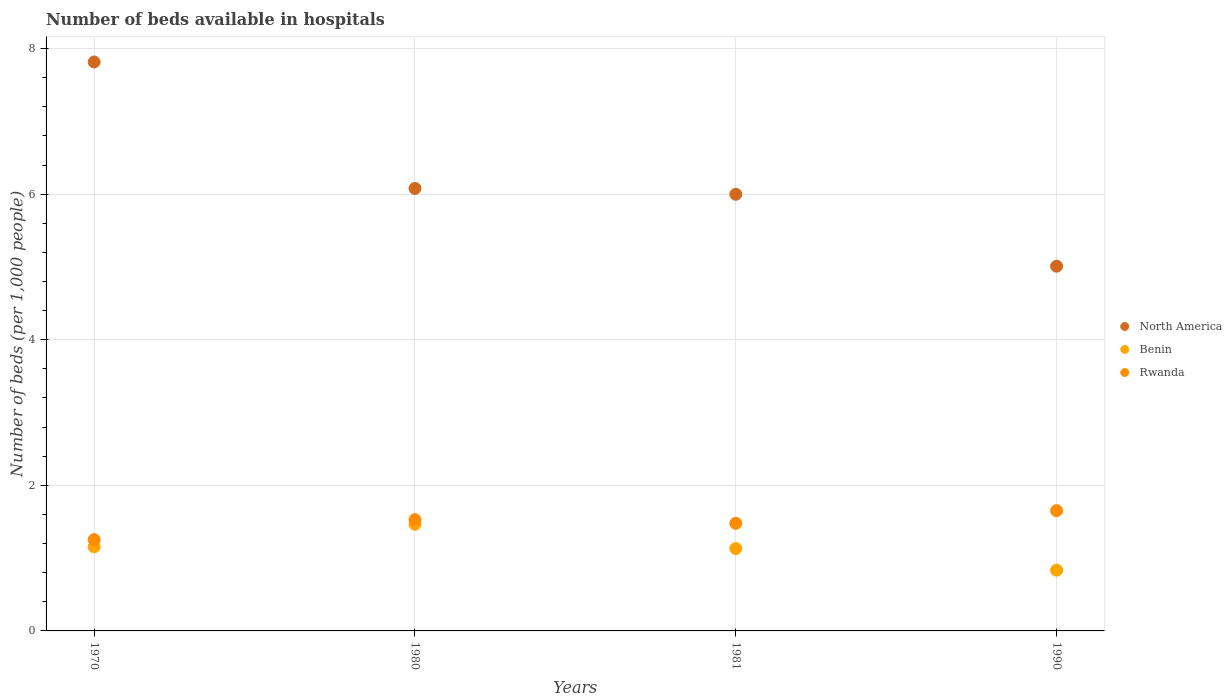How many different coloured dotlines are there?
Offer a very short reply. 3. What is the number of beds in the hospiatls of in Benin in 1970?
Offer a terse response. 1.15. Across all years, what is the maximum number of beds in the hospiatls of in Benin?
Your response must be concise. 1.46. Across all years, what is the minimum number of beds in the hospiatls of in Benin?
Make the answer very short. 0.83. In which year was the number of beds in the hospiatls of in North America minimum?
Make the answer very short. 1990. What is the total number of beds in the hospiatls of in Rwanda in the graph?
Ensure brevity in your answer.  5.91. What is the difference between the number of beds in the hospiatls of in Benin in 1981 and that in 1990?
Ensure brevity in your answer.  0.3. What is the difference between the number of beds in the hospiatls of in North America in 1981 and the number of beds in the hospiatls of in Rwanda in 1970?
Offer a terse response. 4.74. What is the average number of beds in the hospiatls of in Rwanda per year?
Provide a short and direct response. 1.48. In the year 1990, what is the difference between the number of beds in the hospiatls of in North America and number of beds in the hospiatls of in Rwanda?
Your response must be concise. 3.36. In how many years, is the number of beds in the hospiatls of in Benin greater than 3.2?
Give a very brief answer. 0. What is the ratio of the number of beds in the hospiatls of in North America in 1970 to that in 1990?
Make the answer very short. 1.56. Is the number of beds in the hospiatls of in Benin in 1970 less than that in 1990?
Give a very brief answer. No. What is the difference between the highest and the second highest number of beds in the hospiatls of in Benin?
Provide a short and direct response. 0.31. What is the difference between the highest and the lowest number of beds in the hospiatls of in Benin?
Your answer should be very brief. 0.63. In how many years, is the number of beds in the hospiatls of in Benin greater than the average number of beds in the hospiatls of in Benin taken over all years?
Your answer should be very brief. 2. Is the sum of the number of beds in the hospiatls of in Rwanda in 1980 and 1990 greater than the maximum number of beds in the hospiatls of in Benin across all years?
Your answer should be very brief. Yes. Is it the case that in every year, the sum of the number of beds in the hospiatls of in North America and number of beds in the hospiatls of in Benin  is greater than the number of beds in the hospiatls of in Rwanda?
Your response must be concise. Yes. Is the number of beds in the hospiatls of in Benin strictly greater than the number of beds in the hospiatls of in Rwanda over the years?
Your answer should be compact. No. Is the number of beds in the hospiatls of in North America strictly less than the number of beds in the hospiatls of in Rwanda over the years?
Make the answer very short. No. How many dotlines are there?
Your answer should be compact. 3. What is the difference between two consecutive major ticks on the Y-axis?
Make the answer very short. 2. Are the values on the major ticks of Y-axis written in scientific E-notation?
Your answer should be very brief. No. Where does the legend appear in the graph?
Offer a very short reply. Center right. What is the title of the graph?
Provide a succinct answer. Number of beds available in hospitals. What is the label or title of the X-axis?
Offer a terse response. Years. What is the label or title of the Y-axis?
Offer a very short reply. Number of beds (per 1,0 people). What is the Number of beds (per 1,000 people) of North America in 1970?
Give a very brief answer. 7.82. What is the Number of beds (per 1,000 people) in Benin in 1970?
Keep it short and to the point. 1.15. What is the Number of beds (per 1,000 people) in Rwanda in 1970?
Offer a very short reply. 1.25. What is the Number of beds (per 1,000 people) of North America in 1980?
Provide a succinct answer. 6.08. What is the Number of beds (per 1,000 people) in Benin in 1980?
Your answer should be very brief. 1.46. What is the Number of beds (per 1,000 people) of Rwanda in 1980?
Offer a terse response. 1.53. What is the Number of beds (per 1,000 people) of North America in 1981?
Provide a succinct answer. 6. What is the Number of beds (per 1,000 people) of Benin in 1981?
Ensure brevity in your answer.  1.13. What is the Number of beds (per 1,000 people) of Rwanda in 1981?
Offer a terse response. 1.48. What is the Number of beds (per 1,000 people) of North America in 1990?
Keep it short and to the point. 5.01. What is the Number of beds (per 1,000 people) in Benin in 1990?
Offer a terse response. 0.83. What is the Number of beds (per 1,000 people) in Rwanda in 1990?
Keep it short and to the point. 1.65. Across all years, what is the maximum Number of beds (per 1,000 people) of North America?
Keep it short and to the point. 7.82. Across all years, what is the maximum Number of beds (per 1,000 people) in Benin?
Your answer should be very brief. 1.46. Across all years, what is the maximum Number of beds (per 1,000 people) in Rwanda?
Give a very brief answer. 1.65. Across all years, what is the minimum Number of beds (per 1,000 people) of North America?
Give a very brief answer. 5.01. Across all years, what is the minimum Number of beds (per 1,000 people) in Benin?
Your answer should be very brief. 0.83. Across all years, what is the minimum Number of beds (per 1,000 people) in Rwanda?
Offer a terse response. 1.25. What is the total Number of beds (per 1,000 people) of North America in the graph?
Your answer should be very brief. 24.9. What is the total Number of beds (per 1,000 people) in Benin in the graph?
Give a very brief answer. 4.58. What is the total Number of beds (per 1,000 people) in Rwanda in the graph?
Provide a succinct answer. 5.91. What is the difference between the Number of beds (per 1,000 people) of North America in 1970 and that in 1980?
Your answer should be compact. 1.74. What is the difference between the Number of beds (per 1,000 people) in Benin in 1970 and that in 1980?
Offer a very short reply. -0.31. What is the difference between the Number of beds (per 1,000 people) of Rwanda in 1970 and that in 1980?
Your answer should be very brief. -0.27. What is the difference between the Number of beds (per 1,000 people) of North America in 1970 and that in 1981?
Keep it short and to the point. 1.82. What is the difference between the Number of beds (per 1,000 people) of Benin in 1970 and that in 1981?
Provide a short and direct response. 0.02. What is the difference between the Number of beds (per 1,000 people) of Rwanda in 1970 and that in 1981?
Provide a short and direct response. -0.22. What is the difference between the Number of beds (per 1,000 people) in North America in 1970 and that in 1990?
Offer a very short reply. 2.81. What is the difference between the Number of beds (per 1,000 people) of Benin in 1970 and that in 1990?
Offer a very short reply. 0.32. What is the difference between the Number of beds (per 1,000 people) of Rwanda in 1970 and that in 1990?
Give a very brief answer. -0.4. What is the difference between the Number of beds (per 1,000 people) of North America in 1980 and that in 1981?
Offer a terse response. 0.08. What is the difference between the Number of beds (per 1,000 people) of Benin in 1980 and that in 1981?
Provide a short and direct response. 0.33. What is the difference between the Number of beds (per 1,000 people) of Rwanda in 1980 and that in 1981?
Give a very brief answer. 0.05. What is the difference between the Number of beds (per 1,000 people) of North America in 1980 and that in 1990?
Keep it short and to the point. 1.07. What is the difference between the Number of beds (per 1,000 people) in Benin in 1980 and that in 1990?
Make the answer very short. 0.63. What is the difference between the Number of beds (per 1,000 people) in Rwanda in 1980 and that in 1990?
Keep it short and to the point. -0.12. What is the difference between the Number of beds (per 1,000 people) in North America in 1981 and that in 1990?
Offer a very short reply. 0.99. What is the difference between the Number of beds (per 1,000 people) in Benin in 1981 and that in 1990?
Provide a succinct answer. 0.3. What is the difference between the Number of beds (per 1,000 people) in Rwanda in 1981 and that in 1990?
Give a very brief answer. -0.17. What is the difference between the Number of beds (per 1,000 people) in North America in 1970 and the Number of beds (per 1,000 people) in Benin in 1980?
Keep it short and to the point. 6.35. What is the difference between the Number of beds (per 1,000 people) in North America in 1970 and the Number of beds (per 1,000 people) in Rwanda in 1980?
Provide a short and direct response. 6.29. What is the difference between the Number of beds (per 1,000 people) in Benin in 1970 and the Number of beds (per 1,000 people) in Rwanda in 1980?
Offer a very short reply. -0.37. What is the difference between the Number of beds (per 1,000 people) in North America in 1970 and the Number of beds (per 1,000 people) in Benin in 1981?
Make the answer very short. 6.68. What is the difference between the Number of beds (per 1,000 people) of North America in 1970 and the Number of beds (per 1,000 people) of Rwanda in 1981?
Offer a terse response. 6.34. What is the difference between the Number of beds (per 1,000 people) in Benin in 1970 and the Number of beds (per 1,000 people) in Rwanda in 1981?
Make the answer very short. -0.32. What is the difference between the Number of beds (per 1,000 people) in North America in 1970 and the Number of beds (per 1,000 people) in Benin in 1990?
Provide a succinct answer. 6.98. What is the difference between the Number of beds (per 1,000 people) of North America in 1970 and the Number of beds (per 1,000 people) of Rwanda in 1990?
Offer a terse response. 6.16. What is the difference between the Number of beds (per 1,000 people) of Benin in 1970 and the Number of beds (per 1,000 people) of Rwanda in 1990?
Provide a short and direct response. -0.5. What is the difference between the Number of beds (per 1,000 people) in North America in 1980 and the Number of beds (per 1,000 people) in Benin in 1981?
Make the answer very short. 4.95. What is the difference between the Number of beds (per 1,000 people) of North America in 1980 and the Number of beds (per 1,000 people) of Rwanda in 1981?
Your response must be concise. 4.6. What is the difference between the Number of beds (per 1,000 people) in Benin in 1980 and the Number of beds (per 1,000 people) in Rwanda in 1981?
Your answer should be very brief. -0.01. What is the difference between the Number of beds (per 1,000 people) in North America in 1980 and the Number of beds (per 1,000 people) in Benin in 1990?
Your answer should be very brief. 5.24. What is the difference between the Number of beds (per 1,000 people) of North America in 1980 and the Number of beds (per 1,000 people) of Rwanda in 1990?
Make the answer very short. 4.43. What is the difference between the Number of beds (per 1,000 people) of Benin in 1980 and the Number of beds (per 1,000 people) of Rwanda in 1990?
Offer a terse response. -0.19. What is the difference between the Number of beds (per 1,000 people) of North America in 1981 and the Number of beds (per 1,000 people) of Benin in 1990?
Ensure brevity in your answer.  5.16. What is the difference between the Number of beds (per 1,000 people) in North America in 1981 and the Number of beds (per 1,000 people) in Rwanda in 1990?
Your answer should be compact. 4.35. What is the difference between the Number of beds (per 1,000 people) in Benin in 1981 and the Number of beds (per 1,000 people) in Rwanda in 1990?
Your response must be concise. -0.52. What is the average Number of beds (per 1,000 people) in North America per year?
Make the answer very short. 6.23. What is the average Number of beds (per 1,000 people) of Benin per year?
Make the answer very short. 1.15. What is the average Number of beds (per 1,000 people) of Rwanda per year?
Offer a very short reply. 1.48. In the year 1970, what is the difference between the Number of beds (per 1,000 people) in North America and Number of beds (per 1,000 people) in Benin?
Your response must be concise. 6.66. In the year 1970, what is the difference between the Number of beds (per 1,000 people) of North America and Number of beds (per 1,000 people) of Rwanda?
Your answer should be very brief. 6.56. In the year 1970, what is the difference between the Number of beds (per 1,000 people) of Benin and Number of beds (per 1,000 people) of Rwanda?
Provide a succinct answer. -0.1. In the year 1980, what is the difference between the Number of beds (per 1,000 people) of North America and Number of beds (per 1,000 people) of Benin?
Offer a very short reply. 4.61. In the year 1980, what is the difference between the Number of beds (per 1,000 people) in North America and Number of beds (per 1,000 people) in Rwanda?
Keep it short and to the point. 4.55. In the year 1980, what is the difference between the Number of beds (per 1,000 people) in Benin and Number of beds (per 1,000 people) in Rwanda?
Offer a very short reply. -0.06. In the year 1981, what is the difference between the Number of beds (per 1,000 people) of North America and Number of beds (per 1,000 people) of Benin?
Ensure brevity in your answer.  4.87. In the year 1981, what is the difference between the Number of beds (per 1,000 people) in North America and Number of beds (per 1,000 people) in Rwanda?
Your answer should be compact. 4.52. In the year 1981, what is the difference between the Number of beds (per 1,000 people) of Benin and Number of beds (per 1,000 people) of Rwanda?
Provide a succinct answer. -0.35. In the year 1990, what is the difference between the Number of beds (per 1,000 people) of North America and Number of beds (per 1,000 people) of Benin?
Your answer should be very brief. 4.18. In the year 1990, what is the difference between the Number of beds (per 1,000 people) of North America and Number of beds (per 1,000 people) of Rwanda?
Offer a terse response. 3.36. In the year 1990, what is the difference between the Number of beds (per 1,000 people) in Benin and Number of beds (per 1,000 people) in Rwanda?
Provide a succinct answer. -0.82. What is the ratio of the Number of beds (per 1,000 people) in North America in 1970 to that in 1980?
Offer a terse response. 1.29. What is the ratio of the Number of beds (per 1,000 people) in Benin in 1970 to that in 1980?
Your response must be concise. 0.79. What is the ratio of the Number of beds (per 1,000 people) of Rwanda in 1970 to that in 1980?
Make the answer very short. 0.82. What is the ratio of the Number of beds (per 1,000 people) in North America in 1970 to that in 1981?
Offer a terse response. 1.3. What is the ratio of the Number of beds (per 1,000 people) of Benin in 1970 to that in 1981?
Offer a very short reply. 1.02. What is the ratio of the Number of beds (per 1,000 people) of Rwanda in 1970 to that in 1981?
Your response must be concise. 0.85. What is the ratio of the Number of beds (per 1,000 people) of North America in 1970 to that in 1990?
Provide a succinct answer. 1.56. What is the ratio of the Number of beds (per 1,000 people) of Benin in 1970 to that in 1990?
Give a very brief answer. 1.38. What is the ratio of the Number of beds (per 1,000 people) in Rwanda in 1970 to that in 1990?
Your answer should be compact. 0.76. What is the ratio of the Number of beds (per 1,000 people) of North America in 1980 to that in 1981?
Your answer should be compact. 1.01. What is the ratio of the Number of beds (per 1,000 people) of Benin in 1980 to that in 1981?
Ensure brevity in your answer.  1.29. What is the ratio of the Number of beds (per 1,000 people) in Rwanda in 1980 to that in 1981?
Offer a terse response. 1.03. What is the ratio of the Number of beds (per 1,000 people) in North America in 1980 to that in 1990?
Your answer should be compact. 1.21. What is the ratio of the Number of beds (per 1,000 people) in Benin in 1980 to that in 1990?
Provide a succinct answer. 1.76. What is the ratio of the Number of beds (per 1,000 people) in Rwanda in 1980 to that in 1990?
Ensure brevity in your answer.  0.92. What is the ratio of the Number of beds (per 1,000 people) in North America in 1981 to that in 1990?
Ensure brevity in your answer.  1.2. What is the ratio of the Number of beds (per 1,000 people) of Benin in 1981 to that in 1990?
Provide a succinct answer. 1.36. What is the ratio of the Number of beds (per 1,000 people) of Rwanda in 1981 to that in 1990?
Make the answer very short. 0.89. What is the difference between the highest and the second highest Number of beds (per 1,000 people) of North America?
Keep it short and to the point. 1.74. What is the difference between the highest and the second highest Number of beds (per 1,000 people) of Benin?
Give a very brief answer. 0.31. What is the difference between the highest and the second highest Number of beds (per 1,000 people) of Rwanda?
Offer a very short reply. 0.12. What is the difference between the highest and the lowest Number of beds (per 1,000 people) of North America?
Give a very brief answer. 2.81. What is the difference between the highest and the lowest Number of beds (per 1,000 people) in Benin?
Your response must be concise. 0.63. What is the difference between the highest and the lowest Number of beds (per 1,000 people) of Rwanda?
Ensure brevity in your answer.  0.4. 